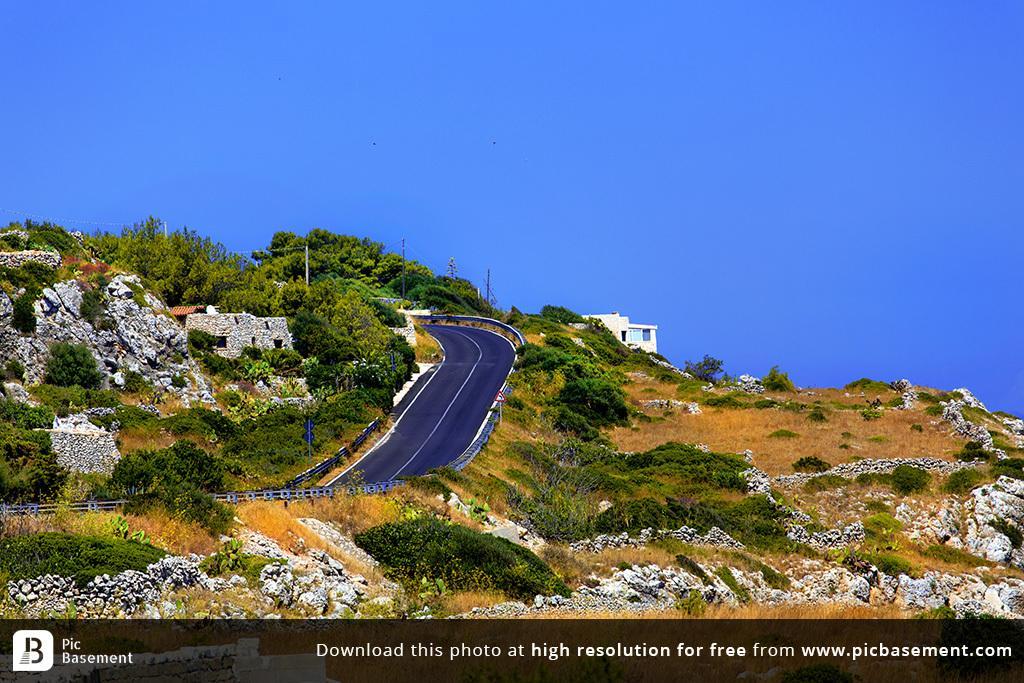Can you describe this image briefly? Here in this picture, in the middle we can see a road present and beside that on the ground we can see grass, plants and trees present and we can also see houses present in the far and we can also see rock stones present and we can see some poles present and we can see the sky is clear. 